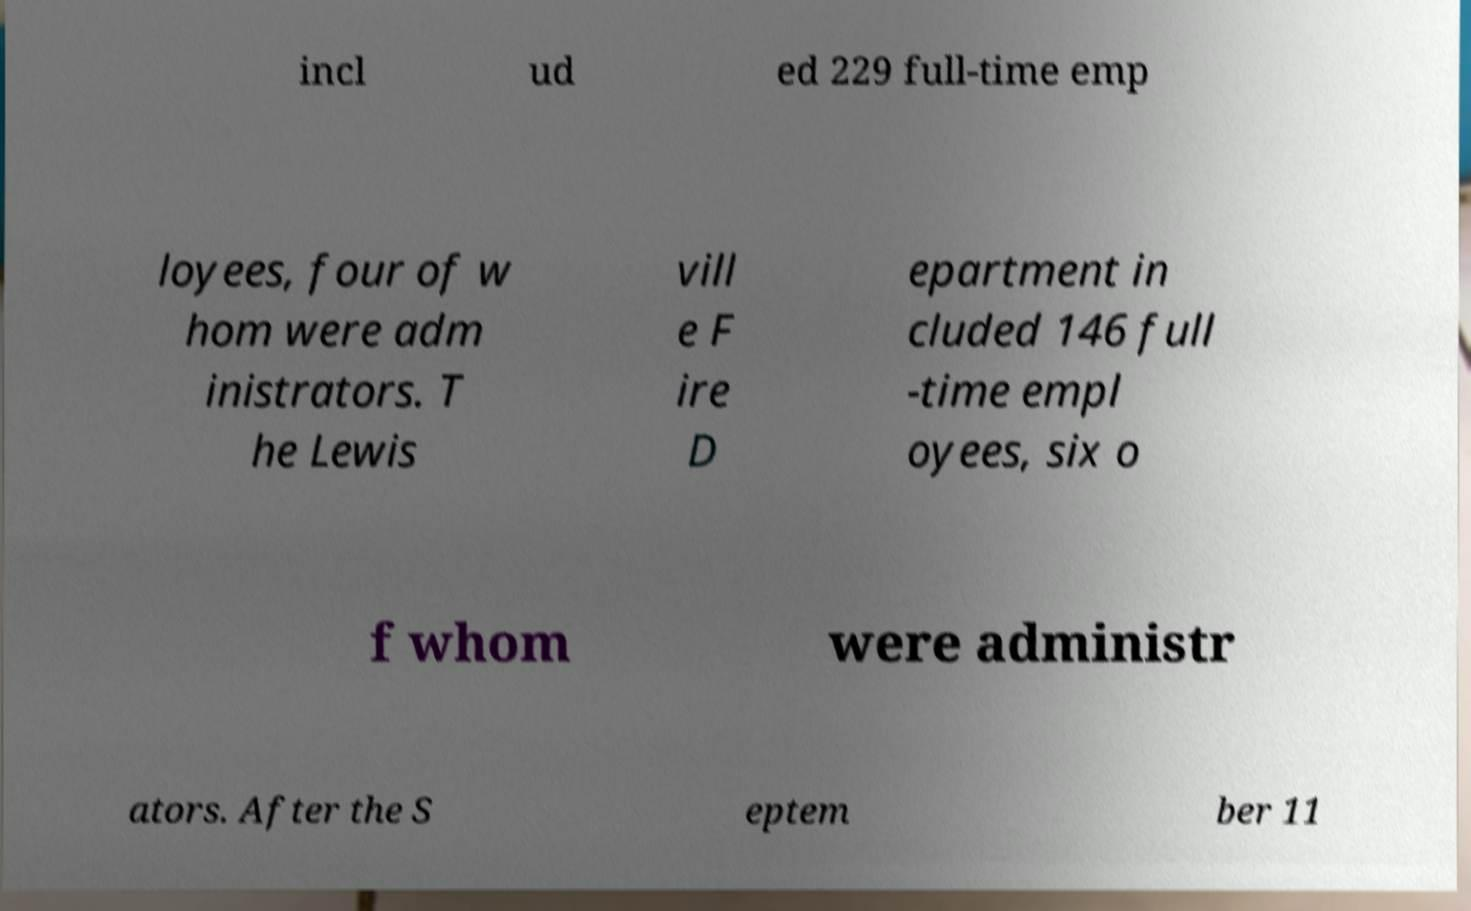Please identify and transcribe the text found in this image. incl ud ed 229 full-time emp loyees, four of w hom were adm inistrators. T he Lewis vill e F ire D epartment in cluded 146 full -time empl oyees, six o f whom were administr ators. After the S eptem ber 11 